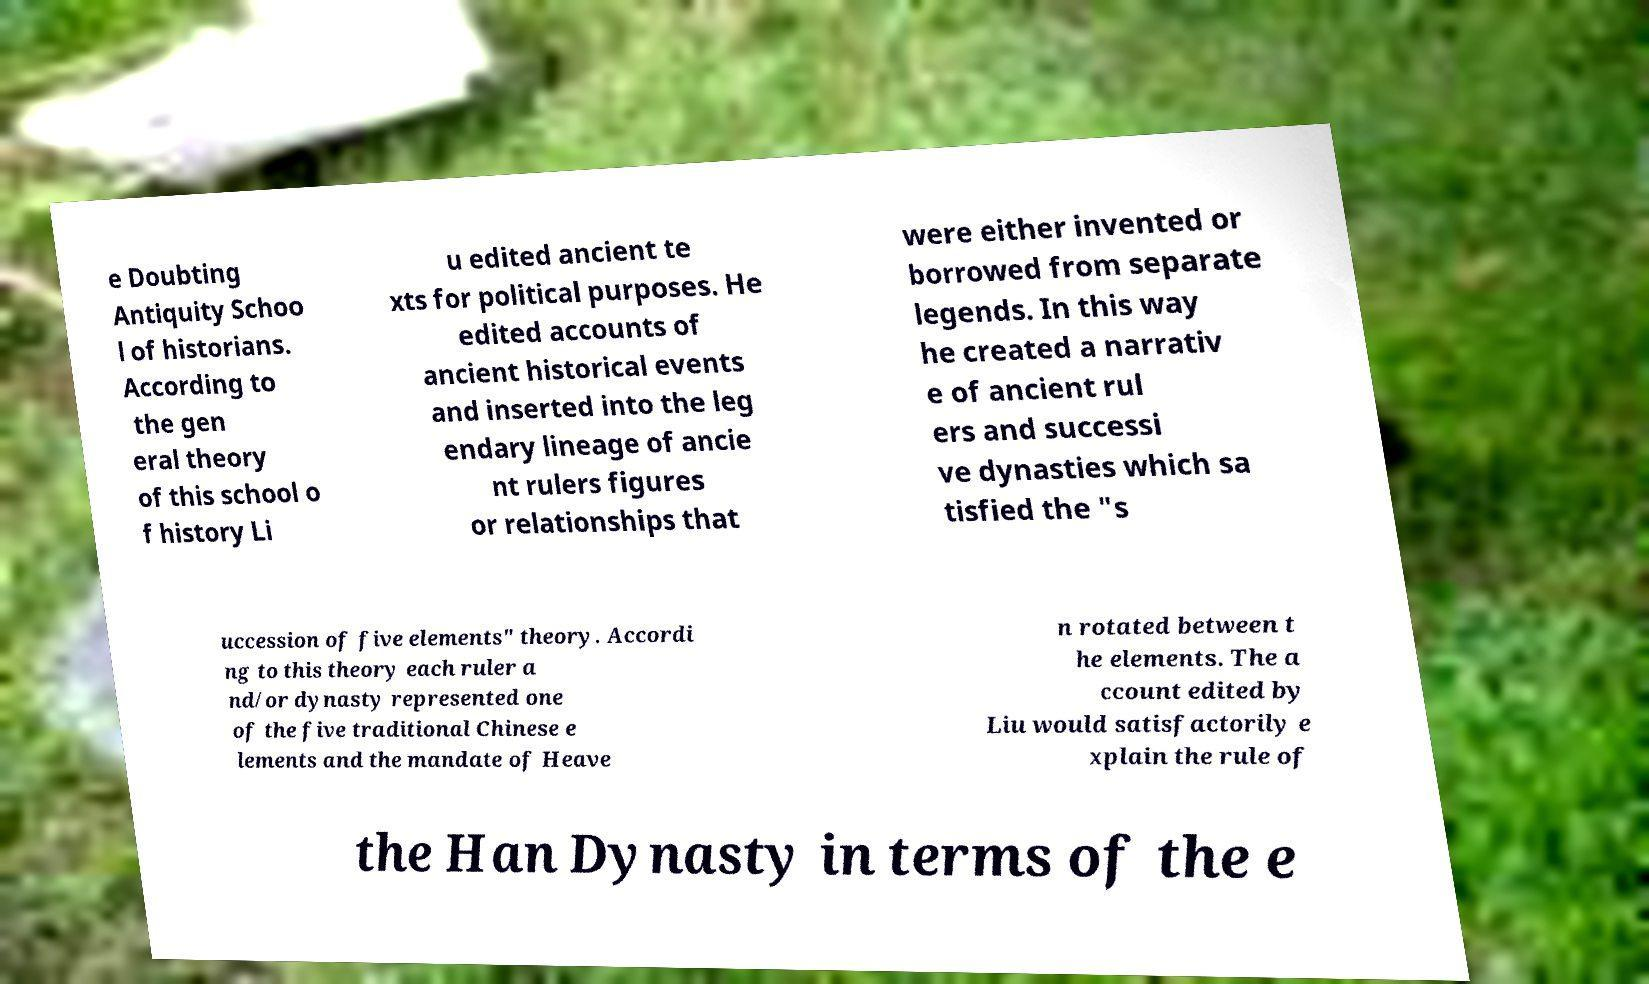Could you assist in decoding the text presented in this image and type it out clearly? e Doubting Antiquity Schoo l of historians. According to the gen eral theory of this school o f history Li u edited ancient te xts for political purposes. He edited accounts of ancient historical events and inserted into the leg endary lineage of ancie nt rulers figures or relationships that were either invented or borrowed from separate legends. In this way he created a narrativ e of ancient rul ers and successi ve dynasties which sa tisfied the "s uccession of five elements" theory. Accordi ng to this theory each ruler a nd/or dynasty represented one of the five traditional Chinese e lements and the mandate of Heave n rotated between t he elements. The a ccount edited by Liu would satisfactorily e xplain the rule of the Han Dynasty in terms of the e 